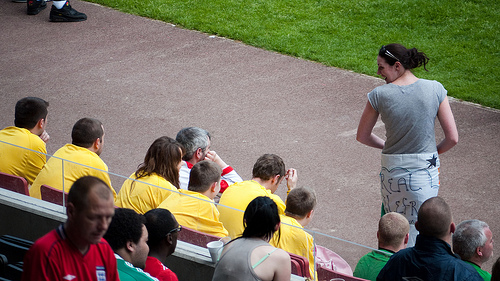<image>
Is there a girl on the boy? No. The girl is not positioned on the boy. They may be near each other, but the girl is not supported by or resting on top of the boy. 